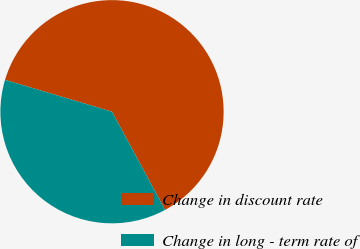<chart> <loc_0><loc_0><loc_500><loc_500><pie_chart><fcel>Change in discount rate<fcel>Change in long - term rate of<nl><fcel>62.5%<fcel>37.5%<nl></chart> 